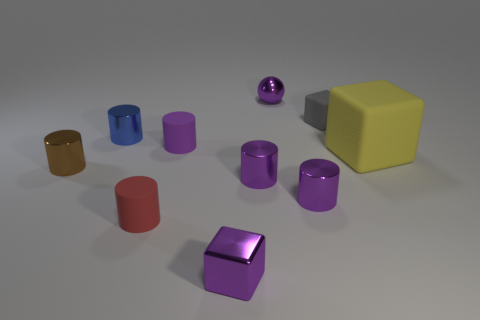How many purple cylinders must be subtracted to get 1 purple cylinders? 2 Subtract all rubber blocks. How many blocks are left? 1 Subtract 1 cubes. How many cubes are left? 2 Subtract all spheres. How many objects are left? 9 Subtract all gray cubes. How many cubes are left? 2 Add 4 tiny red matte cylinders. How many tiny red matte cylinders are left? 5 Add 9 tiny purple matte cylinders. How many tiny purple matte cylinders exist? 10 Subtract 1 purple blocks. How many objects are left? 9 Subtract all cyan spheres. Subtract all purple cylinders. How many spheres are left? 1 Subtract all green blocks. How many yellow spheres are left? 0 